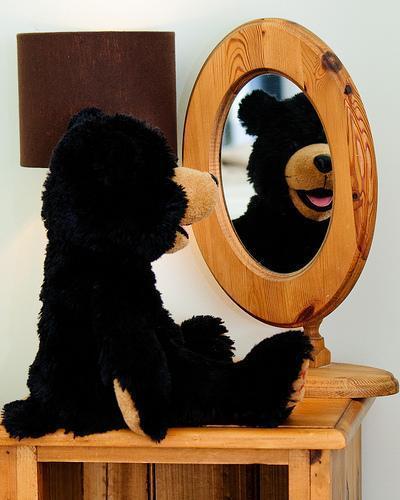How many bears are there?
Give a very brief answer. 1. 